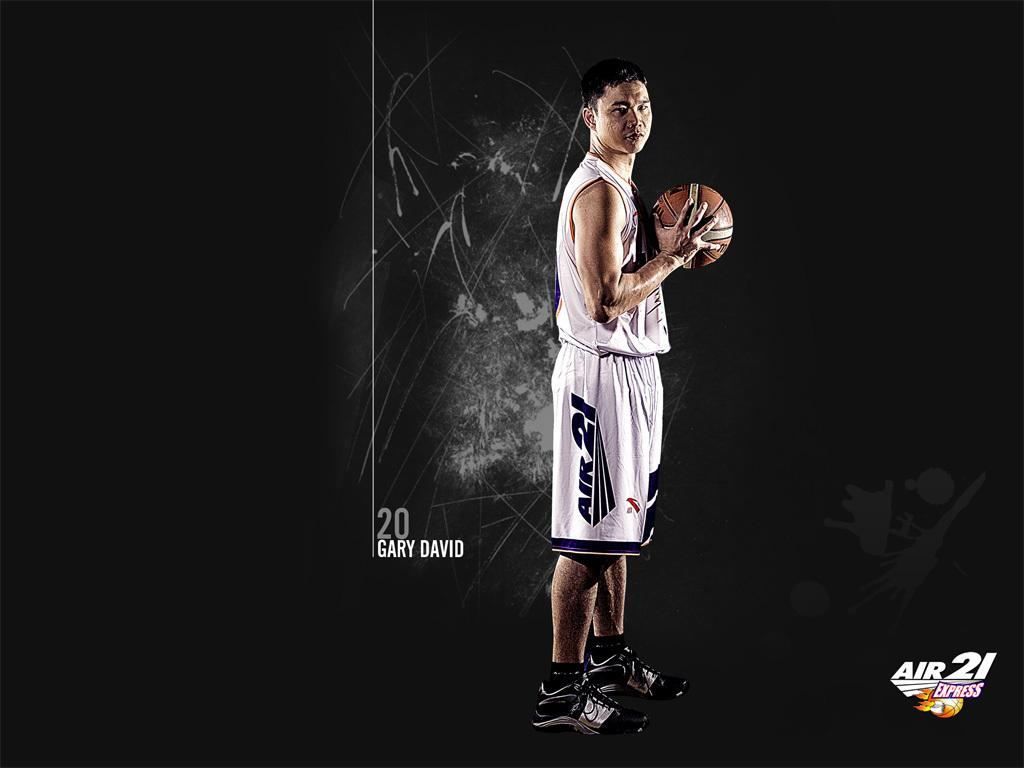What is the person in the image doing? The person is standing in the image. What object is the person holding? The person is holding a ball. What is the person wearing? The person is wearing a white dress. What can be observed about the background of the image? The background of the image is dark. How does the person's wish affect the growth of the jellyfish in the image? There are no jellyfish present in the image, and the person's wish does not affect any growth in the image. 